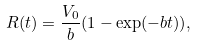<formula> <loc_0><loc_0><loc_500><loc_500>R ( t ) = \frac { V _ { 0 } } { b } ( 1 - \exp ( - b t ) ) ,</formula> 